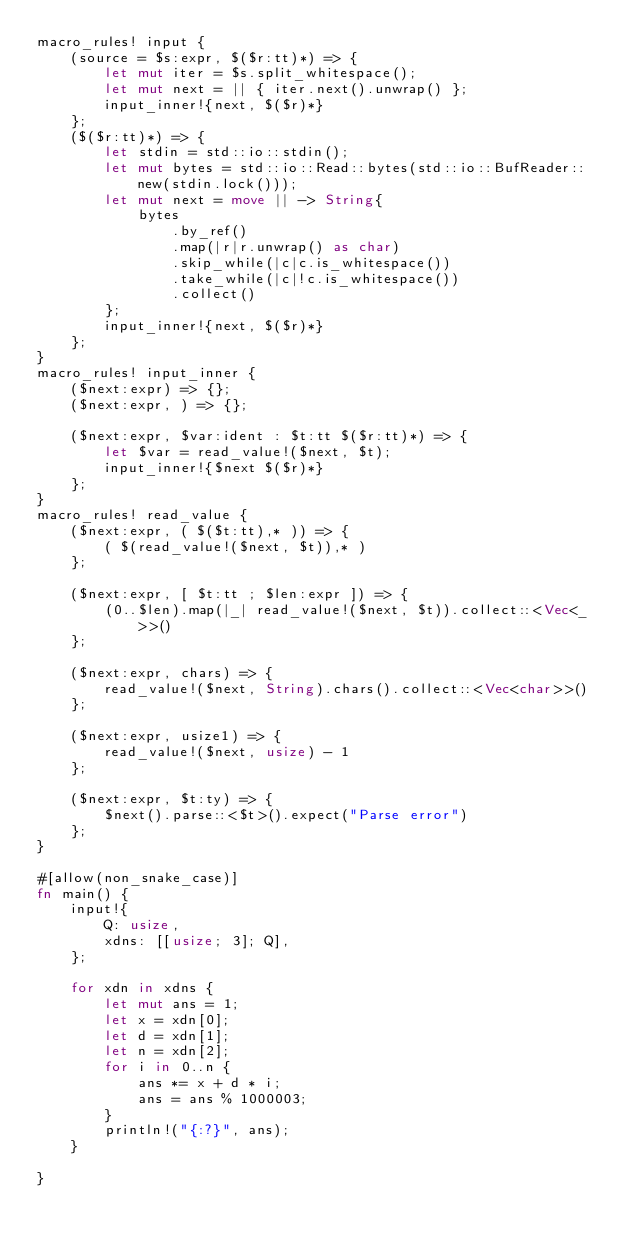Convert code to text. <code><loc_0><loc_0><loc_500><loc_500><_Rust_>macro_rules! input {
    (source = $s:expr, $($r:tt)*) => {
        let mut iter = $s.split_whitespace();
        let mut next = || { iter.next().unwrap() };
        input_inner!{next, $($r)*}
    };
    ($($r:tt)*) => {
        let stdin = std::io::stdin();
        let mut bytes = std::io::Read::bytes(std::io::BufReader::new(stdin.lock()));
        let mut next = move || -> String{
            bytes
                .by_ref()
                .map(|r|r.unwrap() as char)
                .skip_while(|c|c.is_whitespace())
                .take_while(|c|!c.is_whitespace())
                .collect()
        };
        input_inner!{next, $($r)*}
    };
}
macro_rules! input_inner {
    ($next:expr) => {};
    ($next:expr, ) => {};

    ($next:expr, $var:ident : $t:tt $($r:tt)*) => {
        let $var = read_value!($next, $t);
        input_inner!{$next $($r)*}
    };
}
macro_rules! read_value {
    ($next:expr, ( $($t:tt),* )) => {
        ( $(read_value!($next, $t)),* )
    };

    ($next:expr, [ $t:tt ; $len:expr ]) => {
        (0..$len).map(|_| read_value!($next, $t)).collect::<Vec<_>>()
    };

    ($next:expr, chars) => {
        read_value!($next, String).chars().collect::<Vec<char>>()
    };

    ($next:expr, usize1) => {
        read_value!($next, usize) - 1
    };

    ($next:expr, $t:ty) => {
        $next().parse::<$t>().expect("Parse error")
    };
}

#[allow(non_snake_case)]
fn main() {
    input!{
        Q: usize,
        xdns: [[usize; 3]; Q],
    };

    for xdn in xdns {
        let mut ans = 1;
        let x = xdn[0];
        let d = xdn[1];
        let n = xdn[2];
        for i in 0..n {
            ans *= x + d * i;
            ans = ans % 1000003;
        }
        println!("{:?}", ans);
    }

}

</code> 